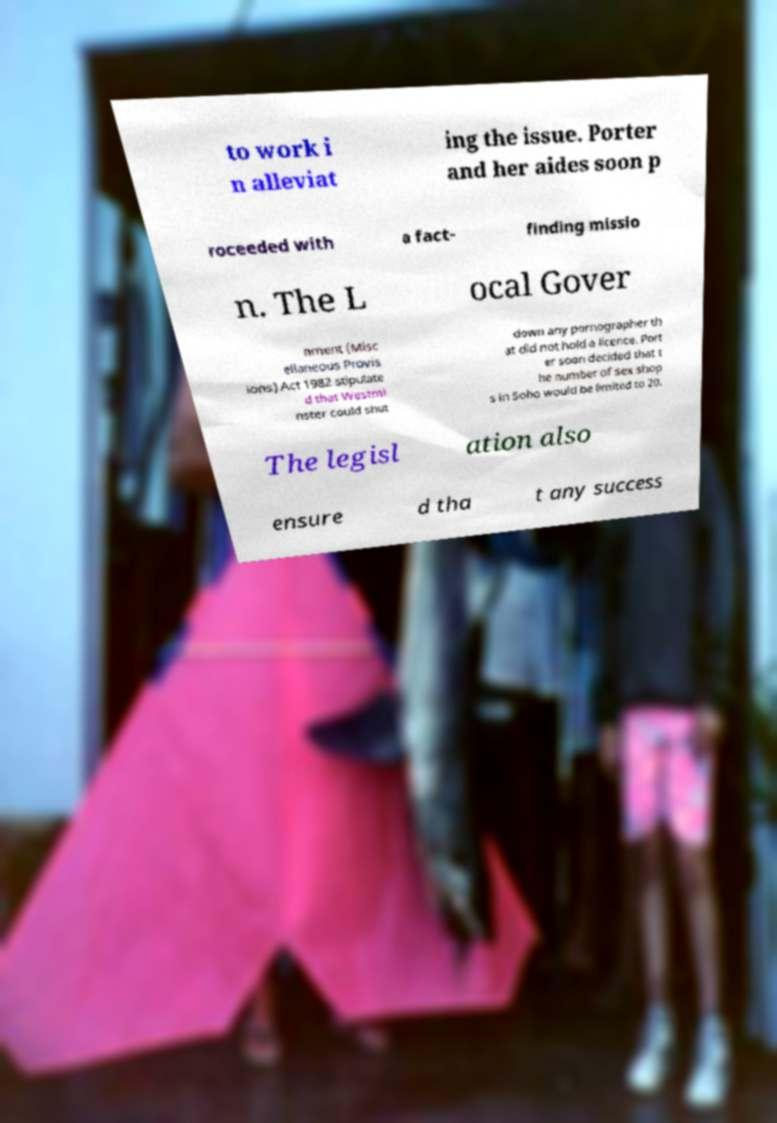I need the written content from this picture converted into text. Can you do that? to work i n alleviat ing the issue. Porter and her aides soon p roceeded with a fact- finding missio n. The L ocal Gover nment (Misc ellaneous Provis ions) Act 1982 stipulate d that Westmi nster could shut down any pornographer th at did not hold a licence. Port er soon decided that t he number of sex shop s in Soho would be limited to 20. The legisl ation also ensure d tha t any success 